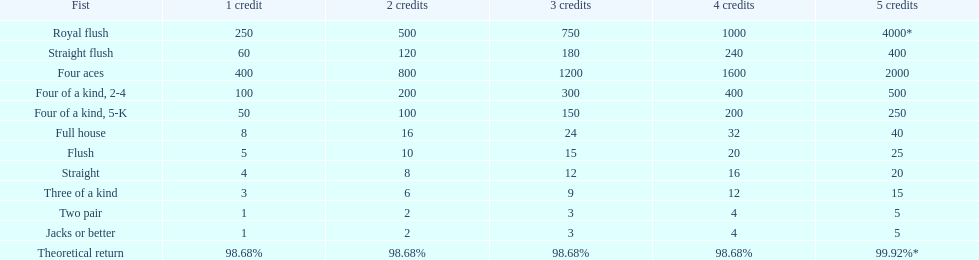How many credits do you have to spend to get at least 2000 in payout if you had four aces? 5 credits. 